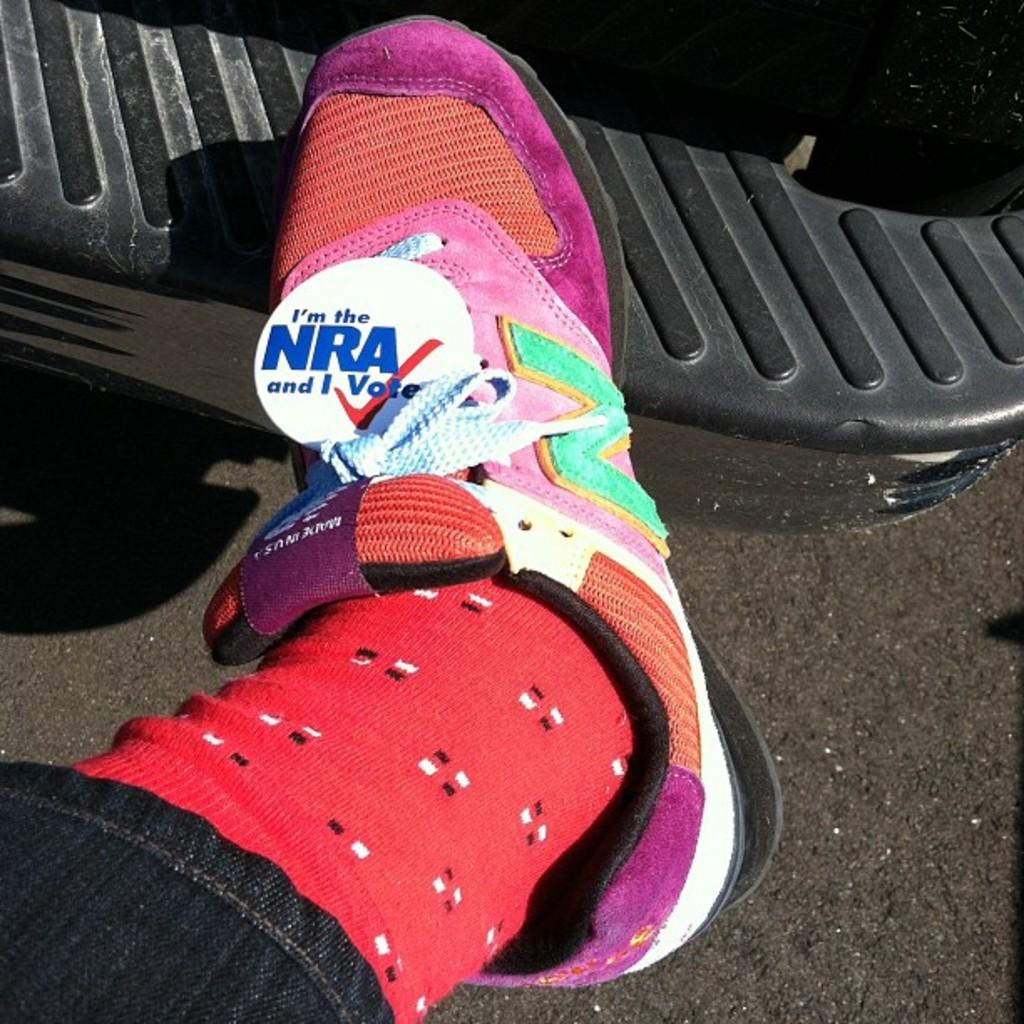Who or what is present in the image? There is a person in the image. What is the person wearing on their feet? The person is wearing a shoe. What color are the socks the person is wearing? The person is wearing red socks. What type of argument is the person having with the hammer in the image? There is no hammer present in the image, and therefore no argument involving a hammer can be observed. 